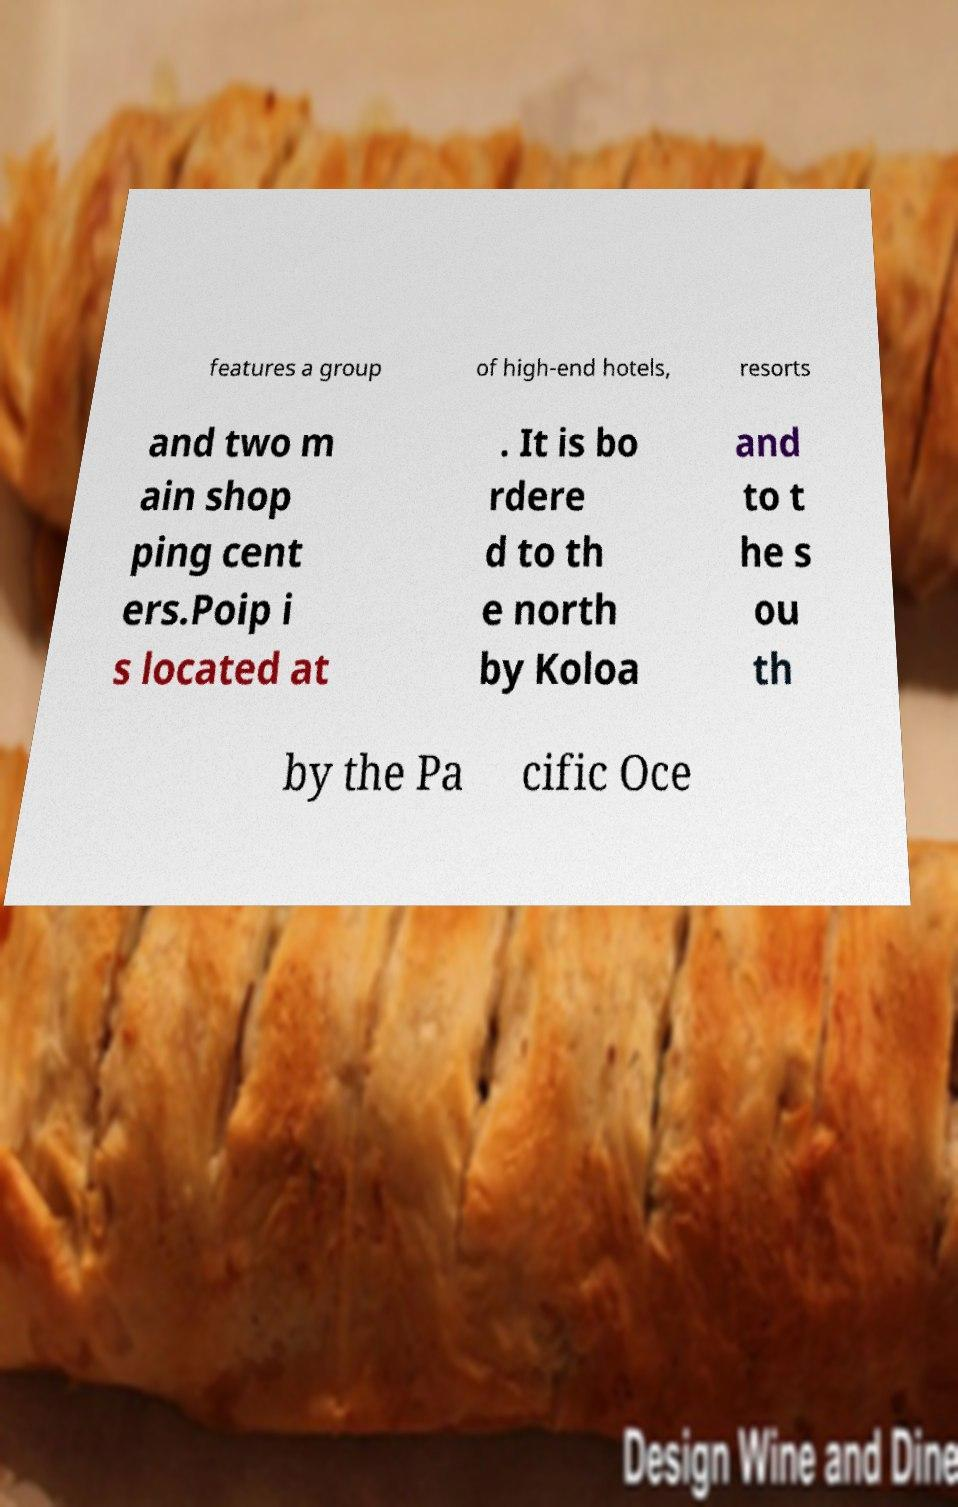What messages or text are displayed in this image? I need them in a readable, typed format. features a group of high-end hotels, resorts and two m ain shop ping cent ers.Poip i s located at . It is bo rdere d to th e north by Koloa and to t he s ou th by the Pa cific Oce 